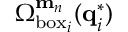<formula> <loc_0><loc_0><loc_500><loc_500>\Omega _ { b o x _ { i } } ^ { m _ { n } } ( q _ { i } ^ { * } )</formula> 